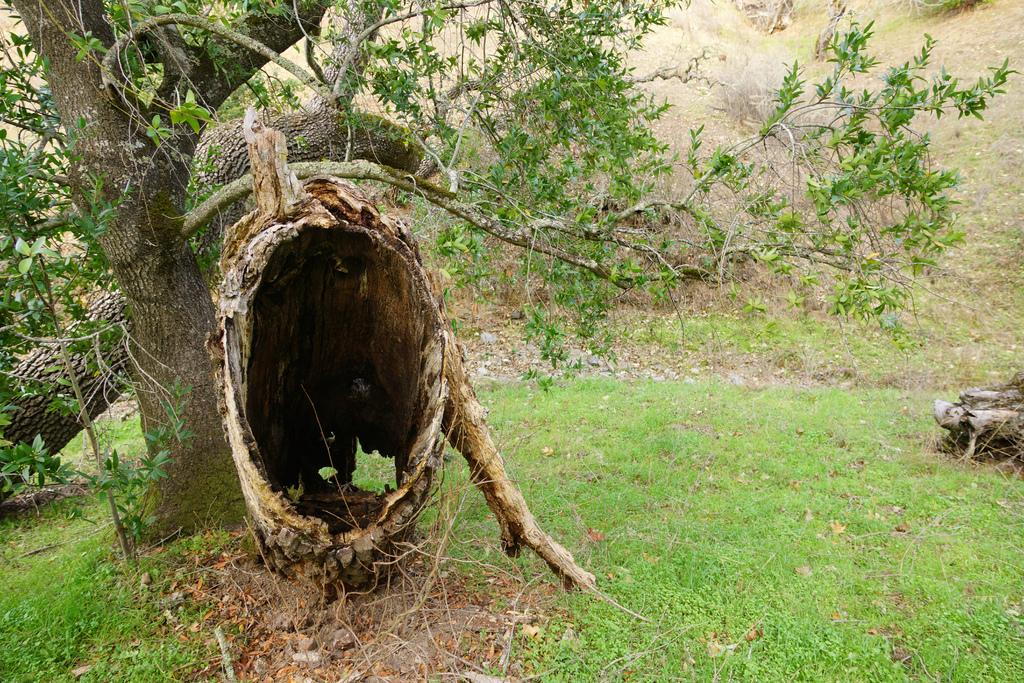What type of vegetation can be seen in the image? There are trees in the image. What is covering the ground in the image? There is grass on the ground in the image. Can you describe any specific details about the trees in the image? There appears to be tree bark on the right side of the image. Where is the person using a fork to eat a glass in the image? There is no person, fork, or glass present in the image. 